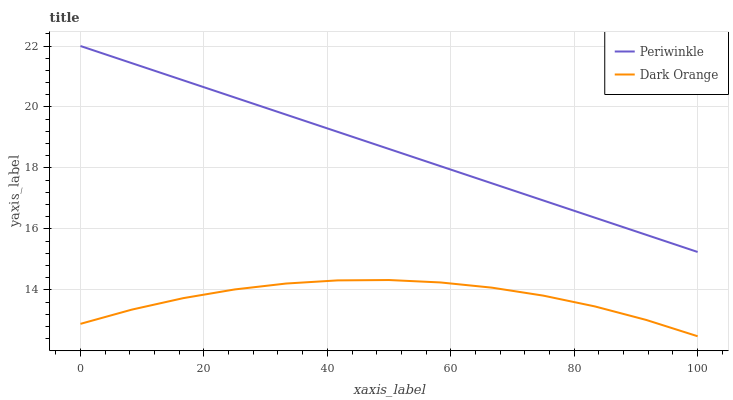Does Dark Orange have the minimum area under the curve?
Answer yes or no. Yes. Does Periwinkle have the maximum area under the curve?
Answer yes or no. Yes. Does Periwinkle have the minimum area under the curve?
Answer yes or no. No. Is Periwinkle the smoothest?
Answer yes or no. Yes. Is Dark Orange the roughest?
Answer yes or no. Yes. Is Periwinkle the roughest?
Answer yes or no. No. Does Dark Orange have the lowest value?
Answer yes or no. Yes. Does Periwinkle have the lowest value?
Answer yes or no. No. Does Periwinkle have the highest value?
Answer yes or no. Yes. Is Dark Orange less than Periwinkle?
Answer yes or no. Yes. Is Periwinkle greater than Dark Orange?
Answer yes or no. Yes. Does Dark Orange intersect Periwinkle?
Answer yes or no. No. 